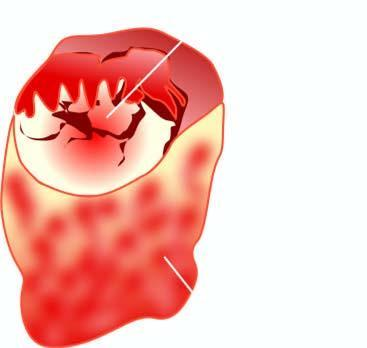what does cut surface of the enlarged thyroid gland show?
Answer the question using a single word or phrase. A single nodule separated from the rest of thyroid parenchyma by incomplete fibrous septa 